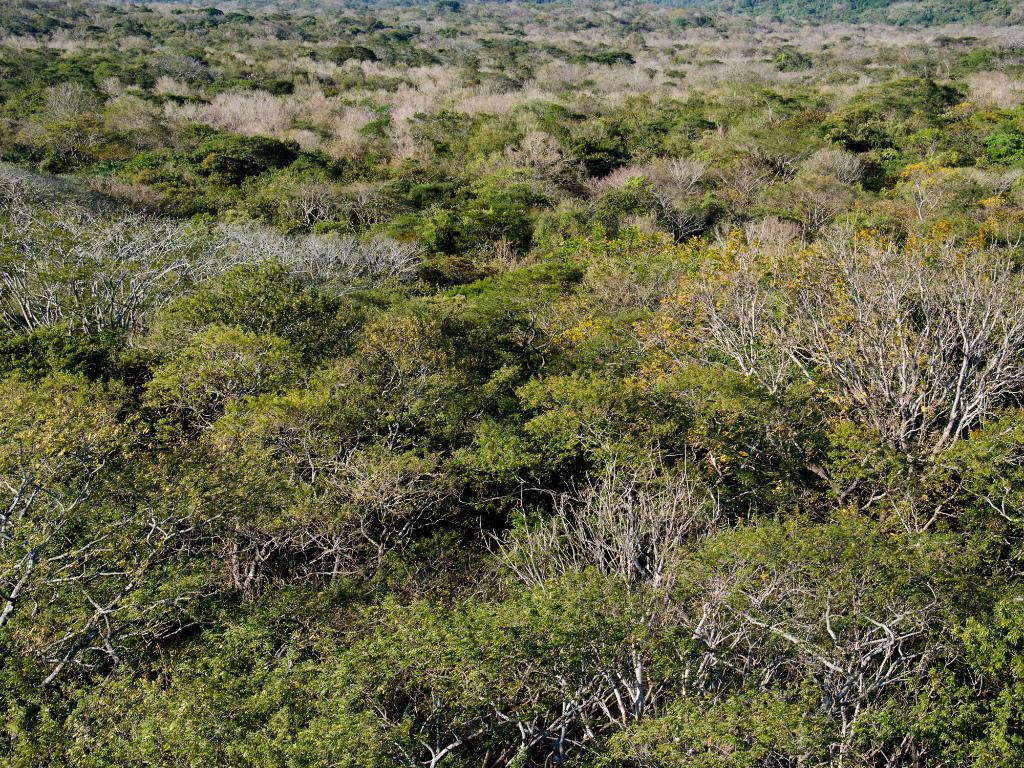What type of vegetation can be seen in the image? There are trees in the image. Can you see any yaks grazing among the trees in the image? There are no yaks present in the image; it only features trees. Are there any playing cards visible among the trees in the image? There are no playing cards present in the image; it only features trees. 